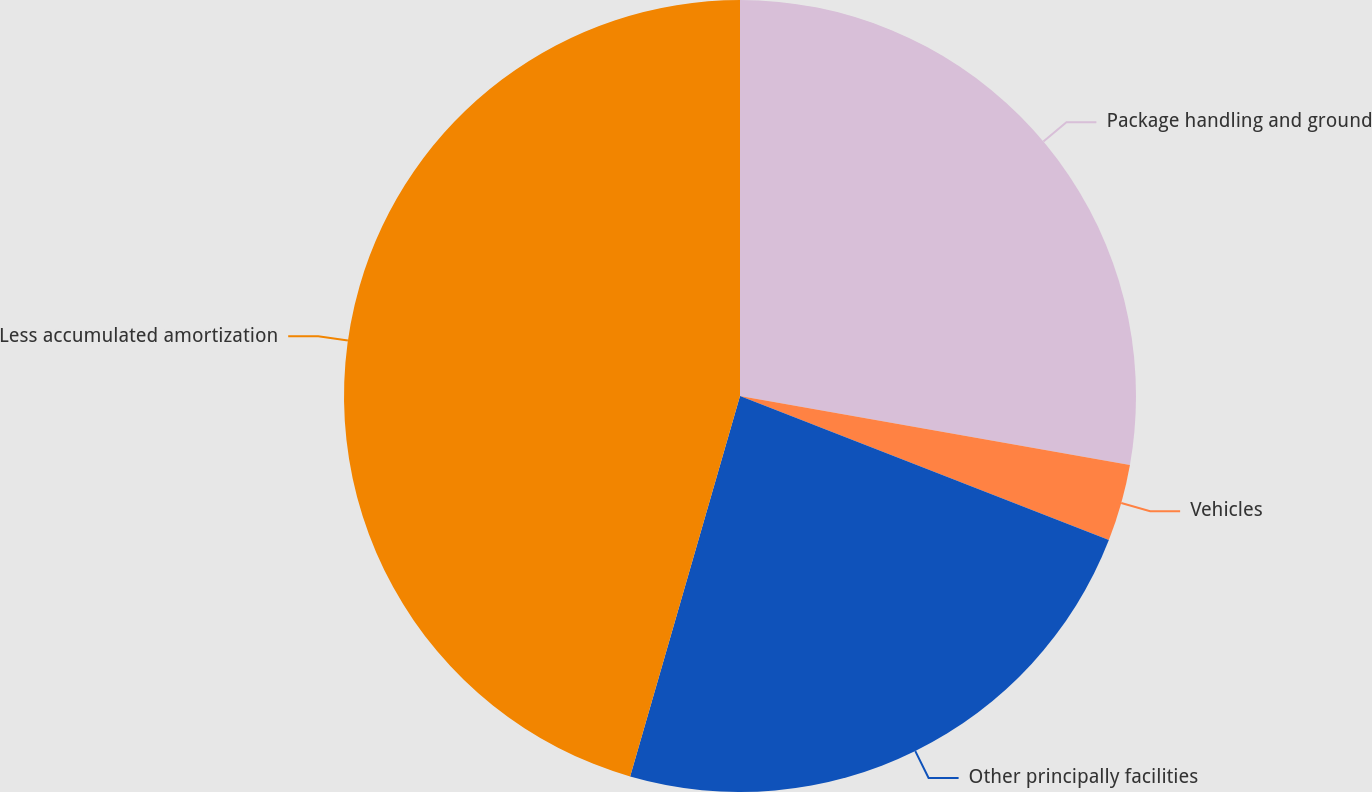Convert chart. <chart><loc_0><loc_0><loc_500><loc_500><pie_chart><fcel>Package handling and ground<fcel>Vehicles<fcel>Other principally facilities<fcel>Less accumulated amortization<nl><fcel>27.79%<fcel>3.14%<fcel>23.55%<fcel>45.53%<nl></chart> 